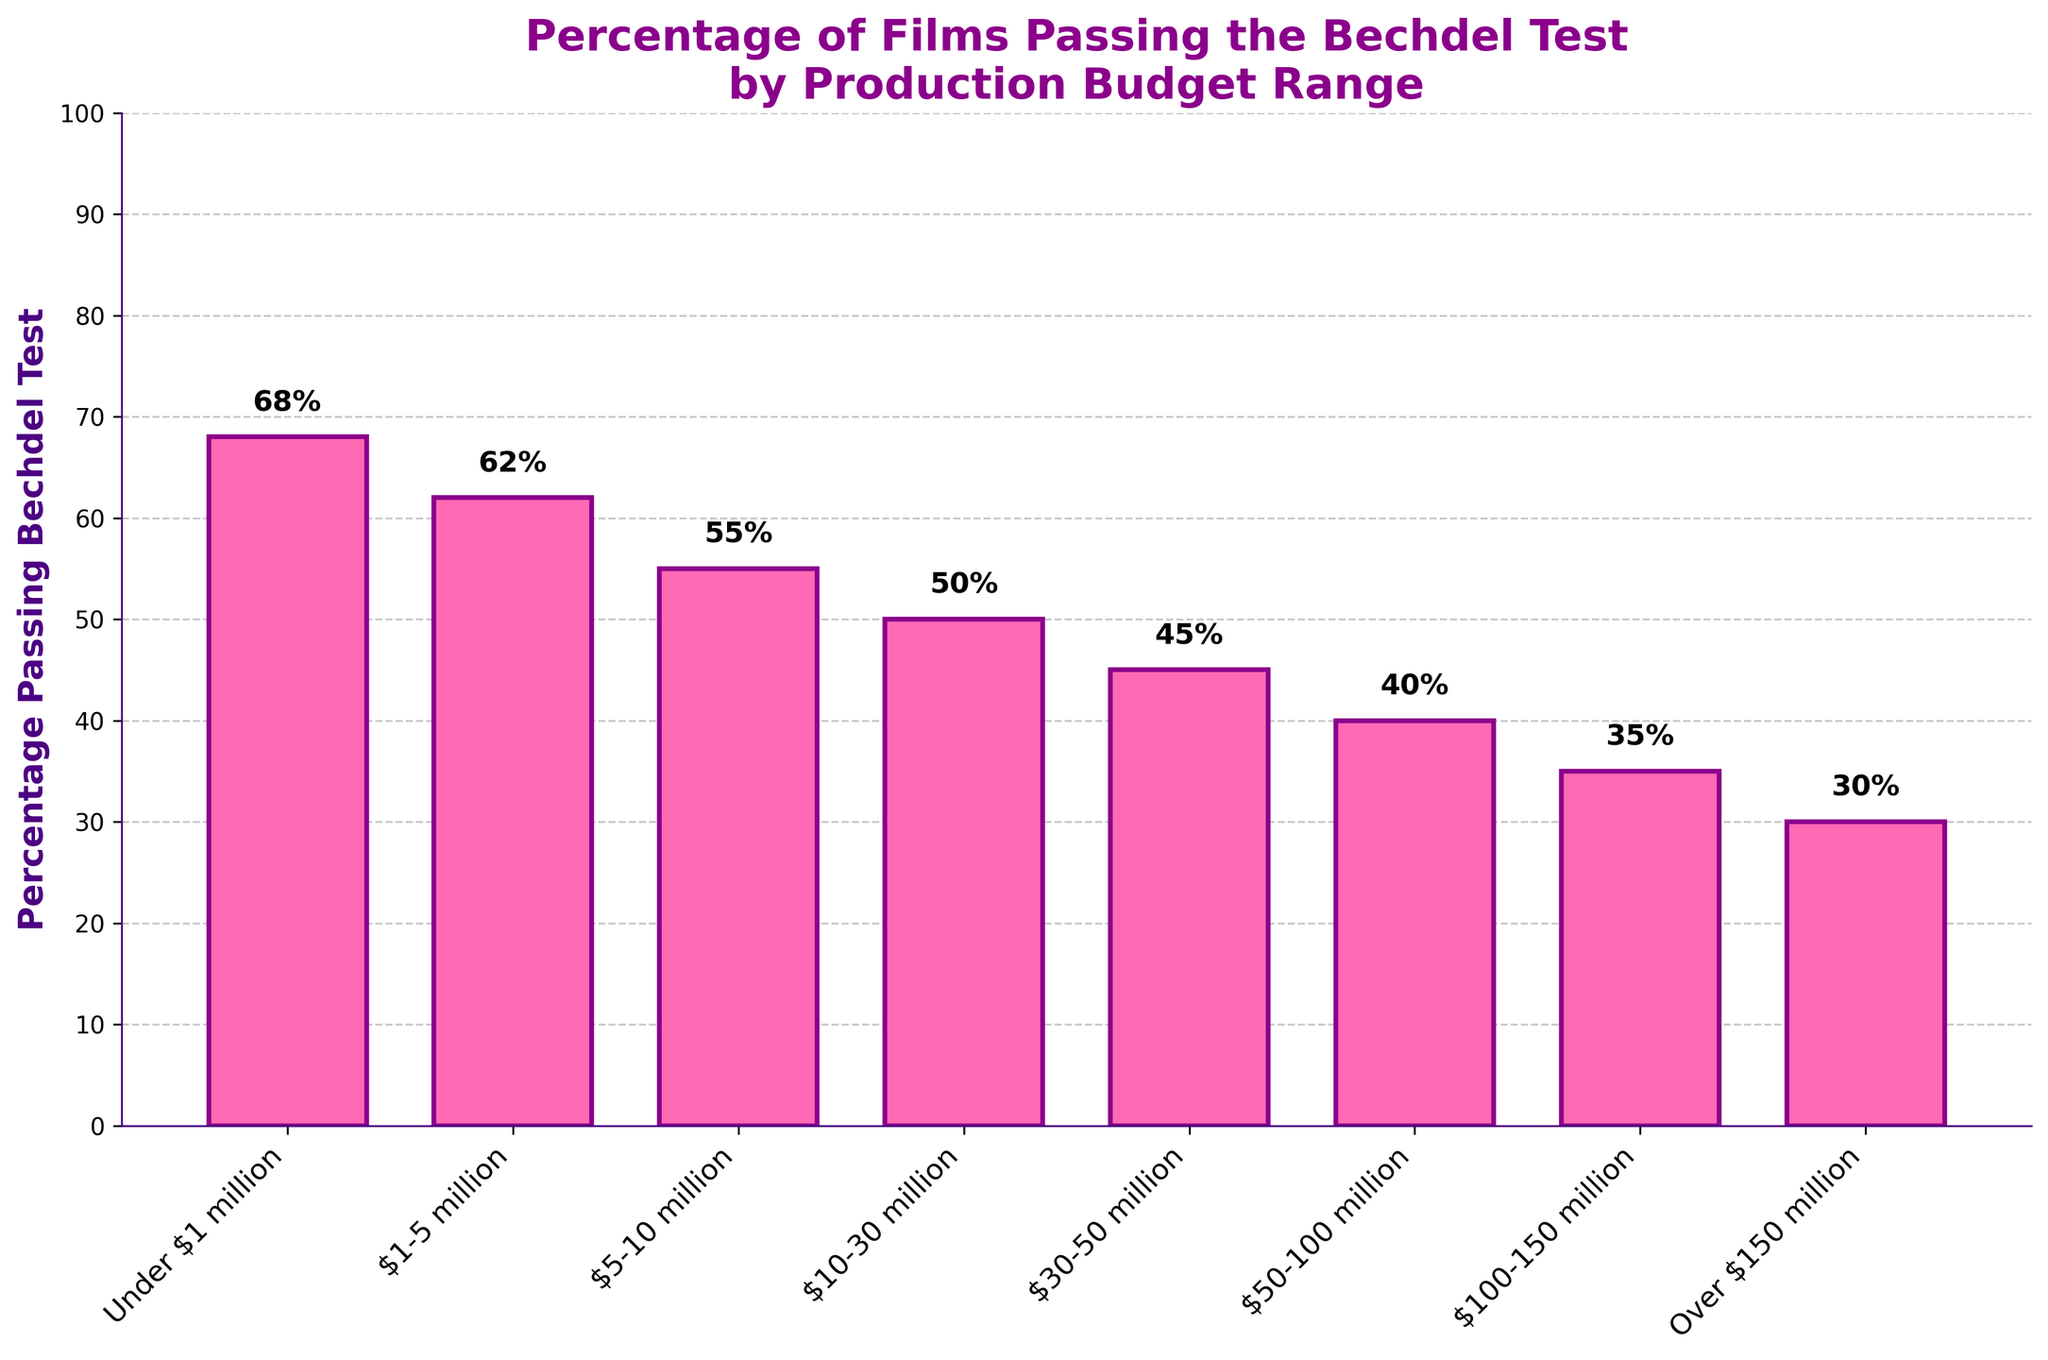Which production budget range has the highest percentage of films passing the Bechdel test? The chart shows different production budget ranges on the x-axis and the percentage of films passing the Bechdel test on the y-axis. The bar for "Under $1 million" is the tallest, indicating the highest percentage.
Answer: Under $1 million Which production budget range has the lowest percentage of films passing the Bechdel test? The bar for "Over $150 million" is the shortest, indicating the lowest percentage of films passing the Bechdel test.
Answer: Over $150 million How much greater is the percentage of films passing the Bechdel test in the "$1-5 million" range compared to the "$30-50 million" range? The percentage for "$1-5 million" is 62% and for "$30-50 million" it is 45%. The difference is 62% - 45% = 17%.
Answer: 17% What is the average percentage of films passing the Bechdel test for budget ranges "$5-10 million" and "$10-30 million"? The percentages are 55% and 50% respectively. The average is calculated as (55% + 50%) / 2 = 52.5%.
Answer: 52.5% Which two production budget ranges have exactly a 10% difference in their percentage of films passing the Bechdel test? Looking at the bars, the "$10-30 million" range has 50% and the "$50-100 million" range has 40%, making the difference 50% - 40% = 10%.
Answer: $10-30 million and $50-100 million Do any production budget ranges have the same percentage of films passing the Bechdel test? By examining the heights of the bars and their corresponding percentages, none of the production budget ranges have the same percentage.
Answer: No By how much does the percentage of films passing the Bechdel test decrease from the "Under $1 million" range to the "Over $150 million" range? The percentage for "Under $1 million" is 68% and for "Over $150 million" it is 30%. The decrease is calculated as 68% - 30% = 38%.
Answer: 38% What is the median percentage of films passing the Bechdel test across all budget ranges? The percentages in ascending order are: 30%, 35%, 40%, 45%, 50%, 55%, 62%, 68%. The median of these 8 values is the average of the 4th and 5th values: (45% + 50%) / 2 = 47.5%.
Answer: 47.5% Which production budget range has a percentage of films passing the Bechdel test closest to the overall average percentage? The overall average is (68 + 62 + 55 + 50 + 45 + 40 + 35 + 30) / 8 = 48.125%. The closest percentage is "10-30 million" with 50%.
Answer: $10-30 million 